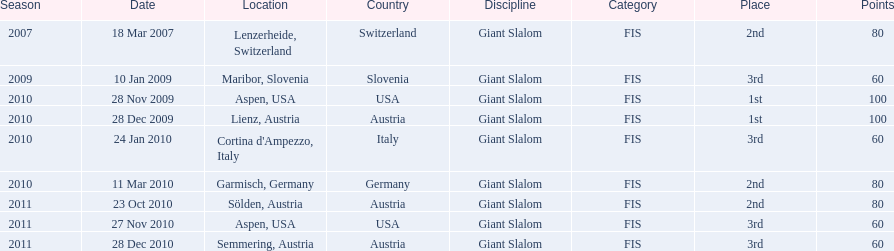What is the total number of her 2nd place finishes on the list? 3. 